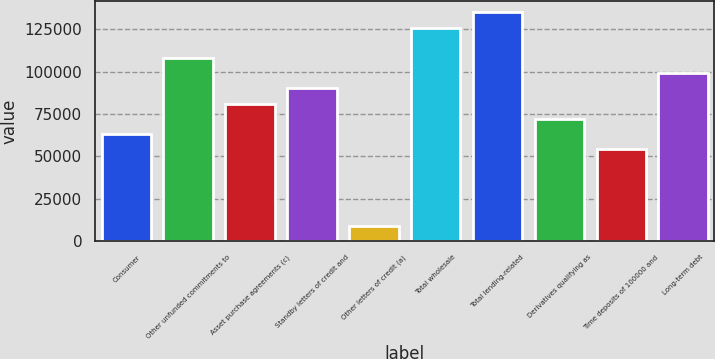Convert chart. <chart><loc_0><loc_0><loc_500><loc_500><bar_chart><fcel>Consumer<fcel>Other unfunded commitments to<fcel>Asset purchase agreements (c)<fcel>Standby letters of credit and<fcel>Other letters of credit (a)<fcel>Total wholesale<fcel>Total lending-related<fcel>Derivatives qualifying as<fcel>Time deposits of 100000 and<fcel>Long-term debt<nl><fcel>63070.2<fcel>108063<fcel>81067.4<fcel>90066<fcel>9078.6<fcel>126060<fcel>135059<fcel>72068.8<fcel>54071.6<fcel>99064.6<nl></chart> 